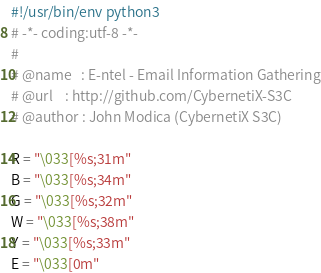<code> <loc_0><loc_0><loc_500><loc_500><_Python_>#!/usr/bin/env python3
# -*- coding:utf-8 -*- 
#
# @name   : E-ntel - Email Information Gathering
# @url    : http://github.com/CybernetiX-S3C
# @author : John Modica (CybernetiX S3C)

R = "\033[%s;31m"
B = "\033[%s;34m"
G = "\033[%s;32m"
W = "\033[%s;38m"
Y = "\033[%s;33m"
E = "\033[0m"</code> 